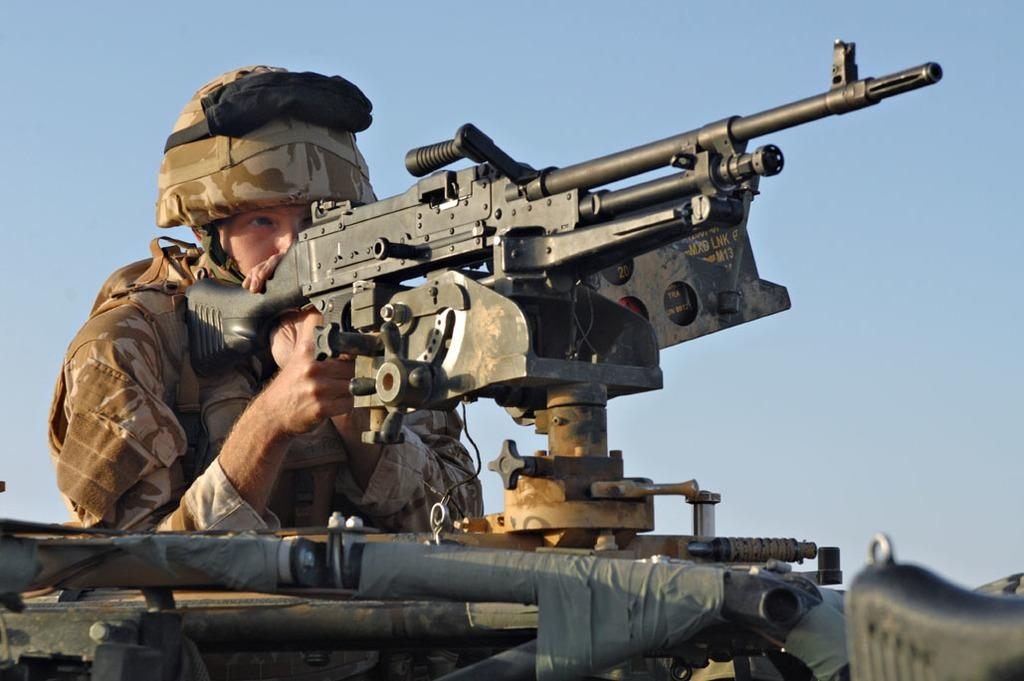Who or what is the main subject of the image? There is a person in the center of the image. What is the person holding in the image? The person is holding a gun. What can be seen in the background of the image? There is sky visible in the background of the image. What type of parcel is being delivered by the person in the image? There is no parcel present in the image; the person is holding a gun. What kind of loaf is the person holding in the image? There is no loaf present in the image; the person is holding a gun. 